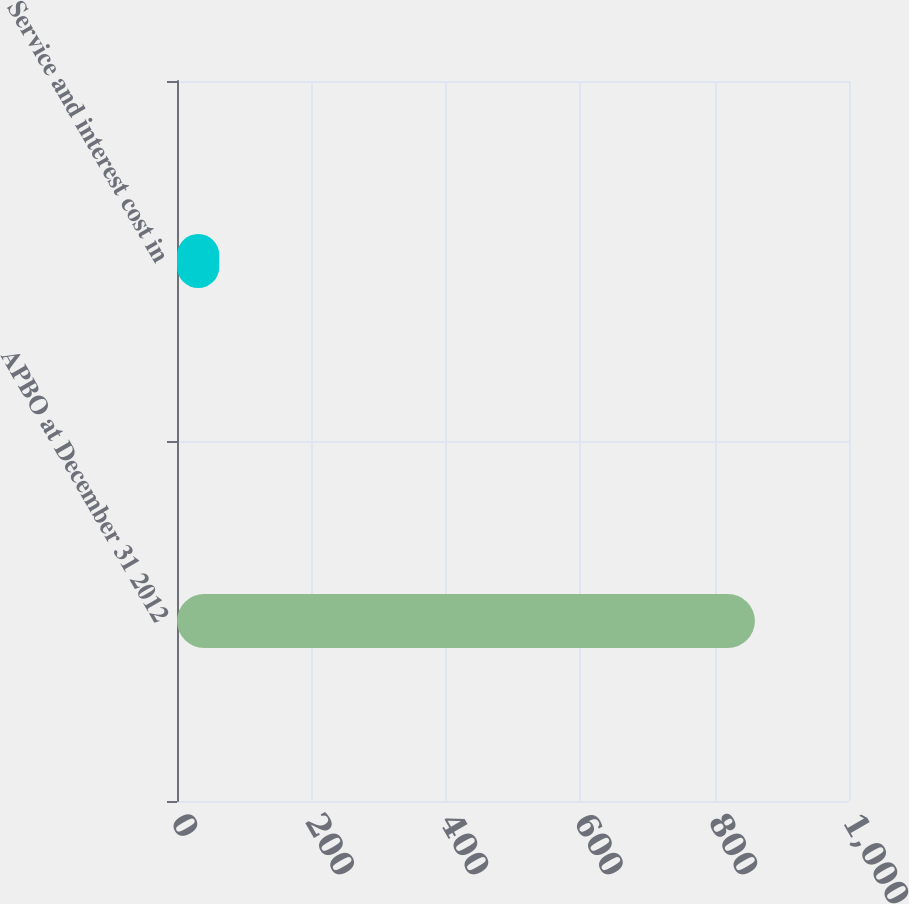<chart> <loc_0><loc_0><loc_500><loc_500><bar_chart><fcel>APBO at December 31 2012<fcel>Service and interest cost in<nl><fcel>860<fcel>63<nl></chart> 